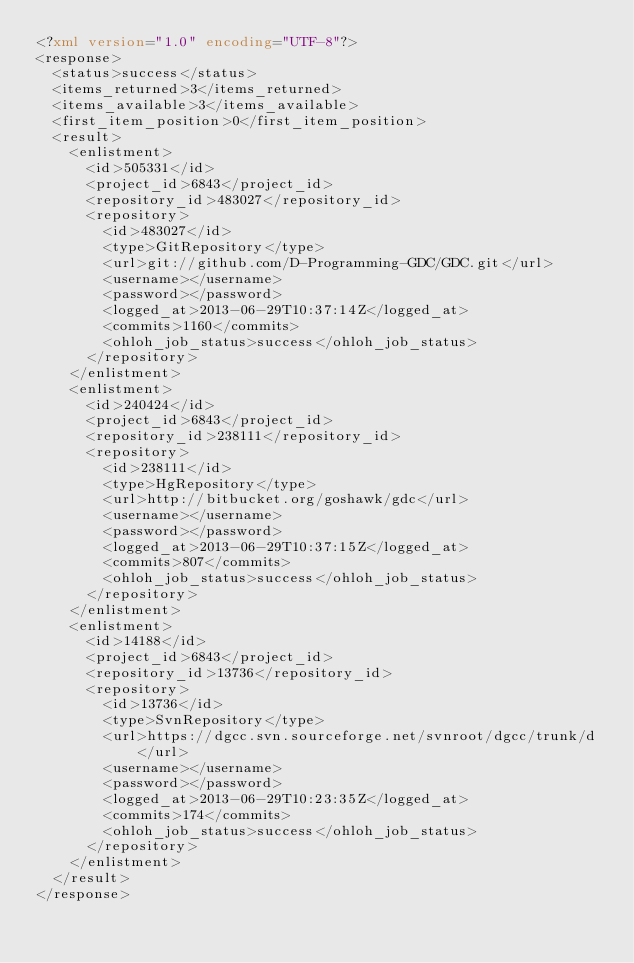Convert code to text. <code><loc_0><loc_0><loc_500><loc_500><_XML_><?xml version="1.0" encoding="UTF-8"?>
<response>
  <status>success</status>
  <items_returned>3</items_returned>
  <items_available>3</items_available>
  <first_item_position>0</first_item_position>
  <result>
    <enlistment>
      <id>505331</id>
      <project_id>6843</project_id>
      <repository_id>483027</repository_id>
      <repository>
        <id>483027</id>
        <type>GitRepository</type>
        <url>git://github.com/D-Programming-GDC/GDC.git</url>
        <username></username>
        <password></password>
        <logged_at>2013-06-29T10:37:14Z</logged_at>
        <commits>1160</commits>
        <ohloh_job_status>success</ohloh_job_status>
      </repository>
    </enlistment>
    <enlistment>
      <id>240424</id>
      <project_id>6843</project_id>
      <repository_id>238111</repository_id>
      <repository>
        <id>238111</id>
        <type>HgRepository</type>
        <url>http://bitbucket.org/goshawk/gdc</url>
        <username></username>
        <password></password>
        <logged_at>2013-06-29T10:37:15Z</logged_at>
        <commits>807</commits>
        <ohloh_job_status>success</ohloh_job_status>
      </repository>
    </enlistment>
    <enlistment>
      <id>14188</id>
      <project_id>6843</project_id>
      <repository_id>13736</repository_id>
      <repository>
        <id>13736</id>
        <type>SvnRepository</type>
        <url>https://dgcc.svn.sourceforge.net/svnroot/dgcc/trunk/d</url>
        <username></username>
        <password></password>
        <logged_at>2013-06-29T10:23:35Z</logged_at>
        <commits>174</commits>
        <ohloh_job_status>success</ohloh_job_status>
      </repository>
    </enlistment>
  </result>
</response>
</code> 